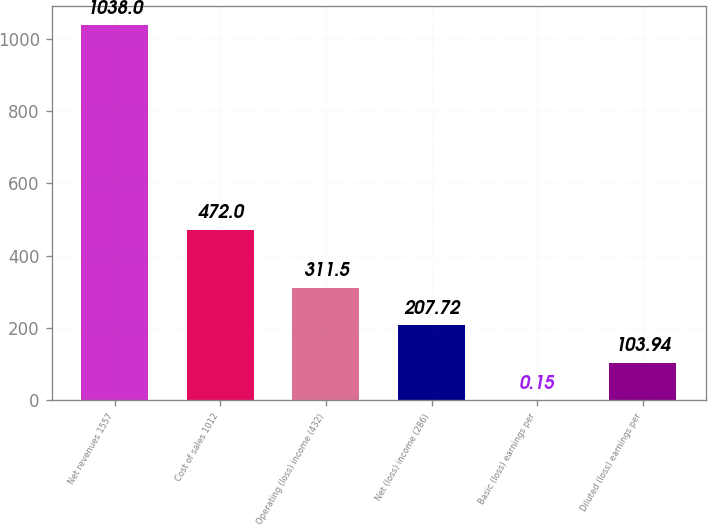Convert chart to OTSL. <chart><loc_0><loc_0><loc_500><loc_500><bar_chart><fcel>Net revenues 1557<fcel>Cost of sales 1012<fcel>Operating (loss) income (432)<fcel>Net (loss) income (286)<fcel>Basic (loss) earnings per<fcel>Diluted (loss) earnings per<nl><fcel>1038<fcel>472<fcel>311.5<fcel>207.72<fcel>0.15<fcel>103.94<nl></chart> 